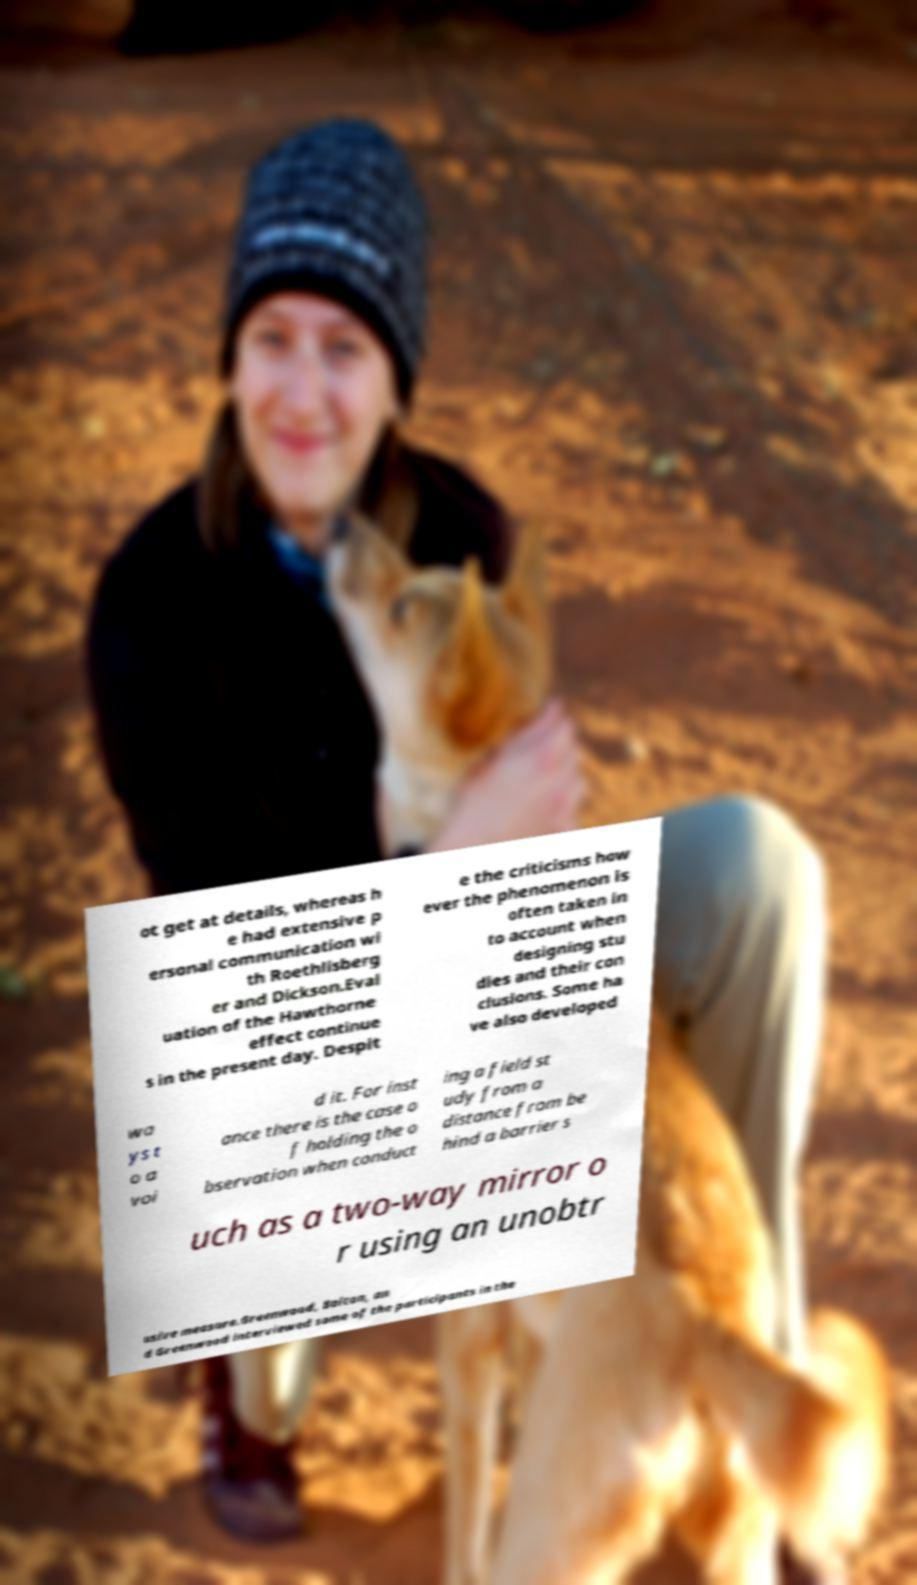Can you read and provide the text displayed in the image?This photo seems to have some interesting text. Can you extract and type it out for me? ot get at details, whereas h e had extensive p ersonal communication wi th Roethlisberg er and Dickson.Eval uation of the Hawthorne effect continue s in the present day. Despit e the criticisms how ever the phenomenon is often taken in to account when designing stu dies and their con clusions. Some ha ve also developed wa ys t o a voi d it. For inst ance there is the case o f holding the o bservation when conduct ing a field st udy from a distance from be hind a barrier s uch as a two-way mirror o r using an unobtr usive measure.Greenwood, Bolton, an d Greenwood interviewed some of the participants in the 